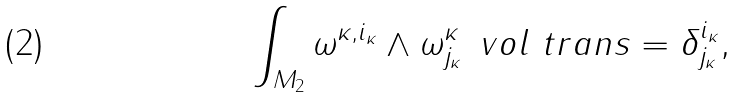<formula> <loc_0><loc_0><loc_500><loc_500>\int _ { M _ { 2 } } \omega ^ { \kappa , i _ { \kappa } } \wedge \omega ^ { \kappa } _ { j _ { \kappa } } \, \ v o l _ { \ } t r a n s = \delta _ { j _ { \kappa } } ^ { i _ { \kappa } } ,</formula> 